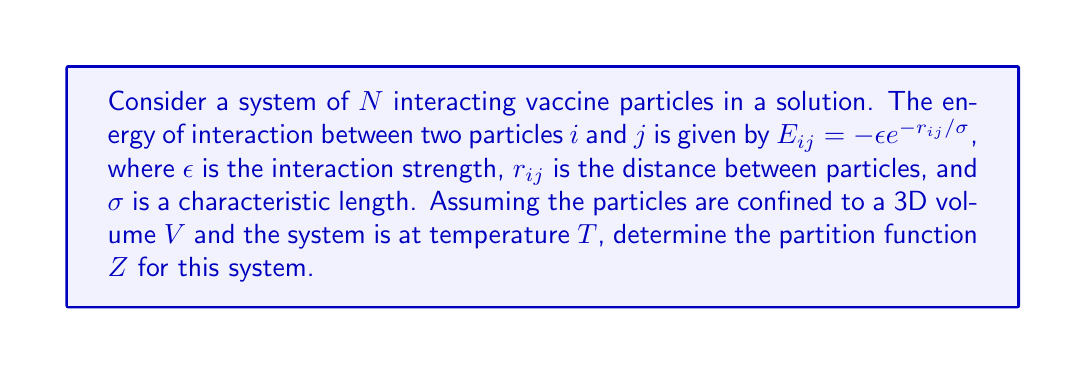Help me with this question. To determine the partition function for this system, we'll follow these steps:

1) The partition function Z for a system of N interacting particles is given by:

   $$Z = \frac{1}{N!} \int ... \int e^{-\beta E_{tot}} d^3r_1 ... d^3r_N$$

   where $\beta = \frac{1}{k_B T}$, and $E_{tot}$ is the total energy of the system.

2) The total energy is the sum of all pairwise interactions:

   $$E_{tot} = \sum_{i<j} E_{ij} = -\epsilon \sum_{i<j} e^{-r_{ij}/\sigma}$$

3) Substituting this into the partition function:

   $$Z = \frac{1}{N!} \int ... \int \exp\left(\beta\epsilon \sum_{i<j} e^{-r_{ij}/\sigma}\right) d^3r_1 ... d^3r_N$$

4) This integral is extremely difficult to evaluate exactly due to the complex interactions between particles. In practice, we often use approximation methods or numerical techniques.

5) One common approximation is the mean-field approach, where we assume each particle interacts with an average field created by all other particles. In this case, we might approximate:

   $$\sum_{i<j} e^{-r_{ij}/\sigma} \approx \frac{N(N-1)}{2} \langle e^{-r/\sigma} \rangle$$

   where $\langle e^{-r/\sigma} \rangle$ is the average value over all possible particle separations.

6) With this approximation, our partition function becomes:

   $$Z \approx \frac{1}{N!} V^N \exp\left(\beta\epsilon \frac{N(N-1)}{2} \langle e^{-r/\sigma} \rangle\right)$$

7) The average $\langle e^{-r/\sigma} \rangle$ depends on the geometry of the system and would need to be calculated based on the specific experimental setup.

This result gives an approximate form of the partition function for the system of interacting vaccine particles, which can be used to derive thermodynamic properties of the system.
Answer: $Z \approx \frac{1}{N!} V^N \exp\left(\beta\epsilon \frac{N(N-1)}{2} \langle e^{-r/\sigma} \rangle\right)$ 